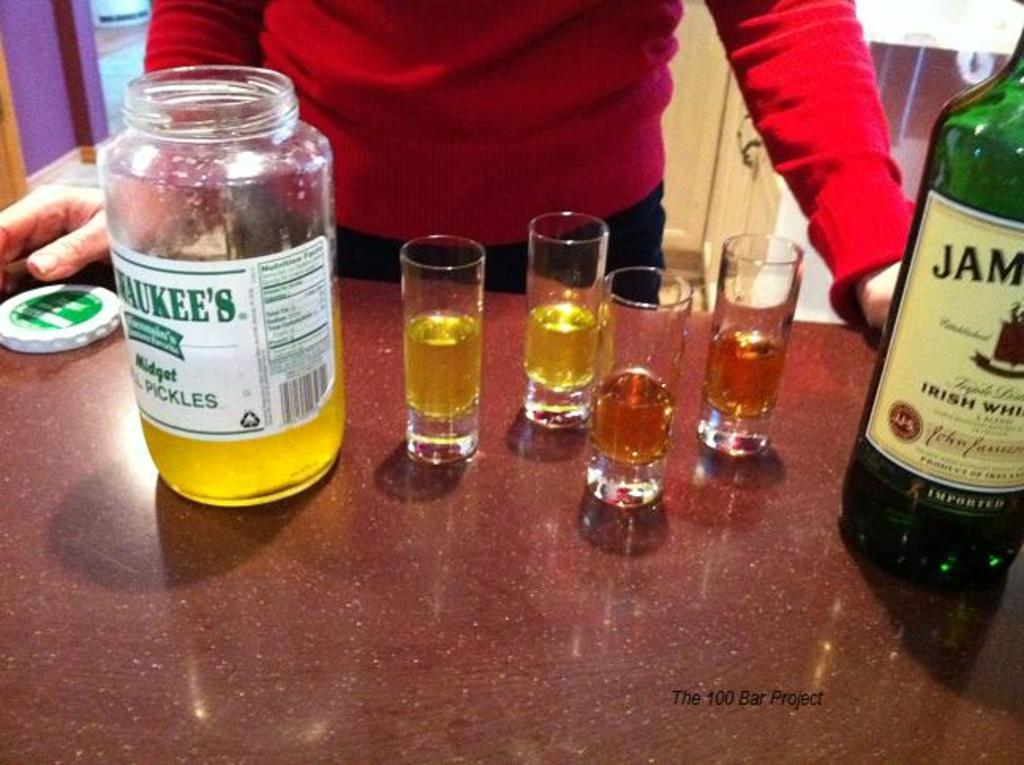<image>
Provide a brief description of the given image. opened bottle with tequile shot glasses of irish whisky 